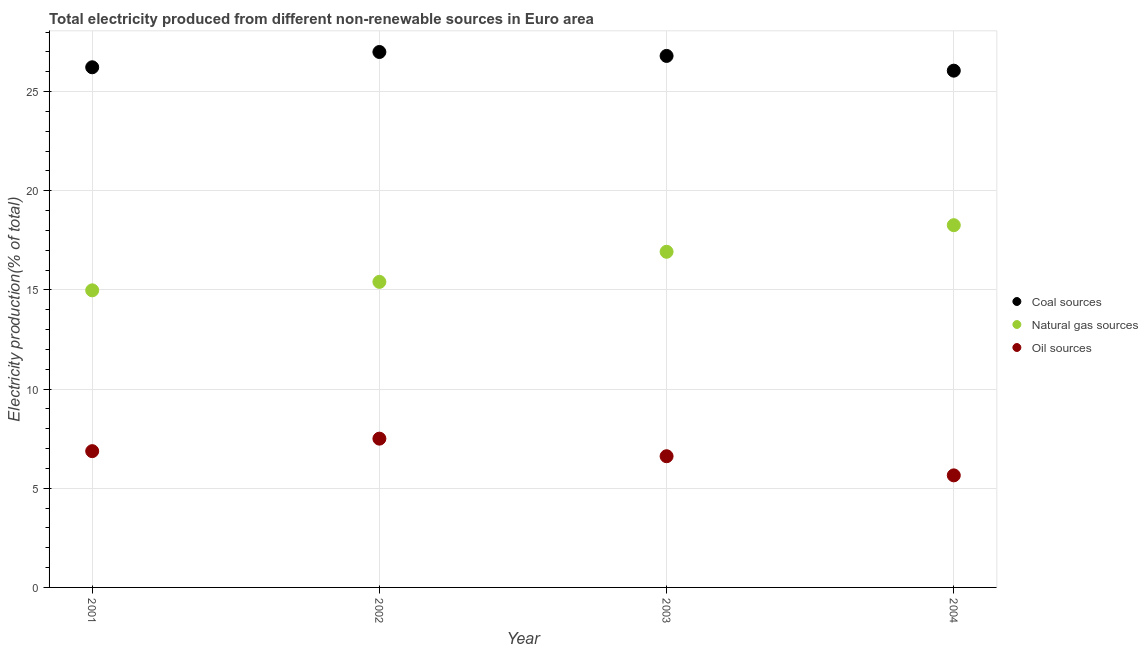How many different coloured dotlines are there?
Your answer should be compact. 3. Is the number of dotlines equal to the number of legend labels?
Give a very brief answer. Yes. What is the percentage of electricity produced by natural gas in 2002?
Ensure brevity in your answer.  15.41. Across all years, what is the maximum percentage of electricity produced by natural gas?
Make the answer very short. 18.26. Across all years, what is the minimum percentage of electricity produced by coal?
Ensure brevity in your answer.  26.06. In which year was the percentage of electricity produced by oil sources maximum?
Provide a short and direct response. 2002. In which year was the percentage of electricity produced by coal minimum?
Your response must be concise. 2004. What is the total percentage of electricity produced by oil sources in the graph?
Offer a very short reply. 26.64. What is the difference between the percentage of electricity produced by oil sources in 2001 and that in 2002?
Give a very brief answer. -0.63. What is the difference between the percentage of electricity produced by oil sources in 2002 and the percentage of electricity produced by natural gas in 2004?
Give a very brief answer. -10.76. What is the average percentage of electricity produced by coal per year?
Your answer should be very brief. 26.52. In the year 2001, what is the difference between the percentage of electricity produced by coal and percentage of electricity produced by oil sources?
Offer a terse response. 19.35. What is the ratio of the percentage of electricity produced by natural gas in 2002 to that in 2004?
Offer a very short reply. 0.84. Is the difference between the percentage of electricity produced by coal in 2002 and 2004 greater than the difference between the percentage of electricity produced by natural gas in 2002 and 2004?
Make the answer very short. Yes. What is the difference between the highest and the second highest percentage of electricity produced by oil sources?
Your answer should be very brief. 0.63. What is the difference between the highest and the lowest percentage of electricity produced by oil sources?
Provide a succinct answer. 1.85. In how many years, is the percentage of electricity produced by coal greater than the average percentage of electricity produced by coal taken over all years?
Your answer should be compact. 2. Is the sum of the percentage of electricity produced by coal in 2002 and 2004 greater than the maximum percentage of electricity produced by oil sources across all years?
Provide a short and direct response. Yes. Is the percentage of electricity produced by coal strictly less than the percentage of electricity produced by oil sources over the years?
Provide a short and direct response. No. How many dotlines are there?
Keep it short and to the point. 3. What is the difference between two consecutive major ticks on the Y-axis?
Your answer should be very brief. 5. Are the values on the major ticks of Y-axis written in scientific E-notation?
Keep it short and to the point. No. Does the graph contain any zero values?
Your answer should be very brief. No. Does the graph contain grids?
Offer a very short reply. Yes. Where does the legend appear in the graph?
Make the answer very short. Center right. What is the title of the graph?
Provide a succinct answer. Total electricity produced from different non-renewable sources in Euro area. Does "Taxes on income" appear as one of the legend labels in the graph?
Give a very brief answer. No. What is the Electricity production(% of total) in Coal sources in 2001?
Provide a short and direct response. 26.23. What is the Electricity production(% of total) in Natural gas sources in 2001?
Your answer should be very brief. 14.98. What is the Electricity production(% of total) in Oil sources in 2001?
Give a very brief answer. 6.87. What is the Electricity production(% of total) of Coal sources in 2002?
Offer a terse response. 27. What is the Electricity production(% of total) in Natural gas sources in 2002?
Give a very brief answer. 15.41. What is the Electricity production(% of total) of Oil sources in 2002?
Provide a succinct answer. 7.5. What is the Electricity production(% of total) of Coal sources in 2003?
Provide a succinct answer. 26.8. What is the Electricity production(% of total) of Natural gas sources in 2003?
Your answer should be compact. 16.92. What is the Electricity production(% of total) of Oil sources in 2003?
Ensure brevity in your answer.  6.62. What is the Electricity production(% of total) in Coal sources in 2004?
Provide a short and direct response. 26.06. What is the Electricity production(% of total) of Natural gas sources in 2004?
Offer a very short reply. 18.26. What is the Electricity production(% of total) in Oil sources in 2004?
Make the answer very short. 5.65. Across all years, what is the maximum Electricity production(% of total) of Coal sources?
Provide a short and direct response. 27. Across all years, what is the maximum Electricity production(% of total) of Natural gas sources?
Give a very brief answer. 18.26. Across all years, what is the maximum Electricity production(% of total) of Oil sources?
Make the answer very short. 7.5. Across all years, what is the minimum Electricity production(% of total) of Coal sources?
Make the answer very short. 26.06. Across all years, what is the minimum Electricity production(% of total) of Natural gas sources?
Your answer should be very brief. 14.98. Across all years, what is the minimum Electricity production(% of total) of Oil sources?
Your answer should be very brief. 5.65. What is the total Electricity production(% of total) of Coal sources in the graph?
Provide a short and direct response. 106.08. What is the total Electricity production(% of total) of Natural gas sources in the graph?
Keep it short and to the point. 65.57. What is the total Electricity production(% of total) in Oil sources in the graph?
Provide a succinct answer. 26.64. What is the difference between the Electricity production(% of total) in Coal sources in 2001 and that in 2002?
Keep it short and to the point. -0.77. What is the difference between the Electricity production(% of total) in Natural gas sources in 2001 and that in 2002?
Your answer should be very brief. -0.43. What is the difference between the Electricity production(% of total) in Oil sources in 2001 and that in 2002?
Offer a terse response. -0.63. What is the difference between the Electricity production(% of total) of Coal sources in 2001 and that in 2003?
Provide a succinct answer. -0.57. What is the difference between the Electricity production(% of total) of Natural gas sources in 2001 and that in 2003?
Your response must be concise. -1.94. What is the difference between the Electricity production(% of total) of Oil sources in 2001 and that in 2003?
Your answer should be very brief. 0.26. What is the difference between the Electricity production(% of total) of Coal sources in 2001 and that in 2004?
Keep it short and to the point. 0.17. What is the difference between the Electricity production(% of total) in Natural gas sources in 2001 and that in 2004?
Keep it short and to the point. -3.28. What is the difference between the Electricity production(% of total) in Oil sources in 2001 and that in 2004?
Keep it short and to the point. 1.22. What is the difference between the Electricity production(% of total) of Coal sources in 2002 and that in 2003?
Provide a succinct answer. 0.2. What is the difference between the Electricity production(% of total) of Natural gas sources in 2002 and that in 2003?
Offer a terse response. -1.52. What is the difference between the Electricity production(% of total) of Oil sources in 2002 and that in 2003?
Your answer should be compact. 0.89. What is the difference between the Electricity production(% of total) of Coal sources in 2002 and that in 2004?
Offer a terse response. 0.94. What is the difference between the Electricity production(% of total) in Natural gas sources in 2002 and that in 2004?
Give a very brief answer. -2.86. What is the difference between the Electricity production(% of total) of Oil sources in 2002 and that in 2004?
Provide a short and direct response. 1.85. What is the difference between the Electricity production(% of total) of Coal sources in 2003 and that in 2004?
Offer a very short reply. 0.74. What is the difference between the Electricity production(% of total) in Natural gas sources in 2003 and that in 2004?
Offer a terse response. -1.34. What is the difference between the Electricity production(% of total) in Oil sources in 2003 and that in 2004?
Provide a succinct answer. 0.96. What is the difference between the Electricity production(% of total) in Coal sources in 2001 and the Electricity production(% of total) in Natural gas sources in 2002?
Offer a terse response. 10.82. What is the difference between the Electricity production(% of total) in Coal sources in 2001 and the Electricity production(% of total) in Oil sources in 2002?
Provide a short and direct response. 18.72. What is the difference between the Electricity production(% of total) of Natural gas sources in 2001 and the Electricity production(% of total) of Oil sources in 2002?
Provide a short and direct response. 7.48. What is the difference between the Electricity production(% of total) in Coal sources in 2001 and the Electricity production(% of total) in Natural gas sources in 2003?
Your answer should be compact. 9.3. What is the difference between the Electricity production(% of total) in Coal sources in 2001 and the Electricity production(% of total) in Oil sources in 2003?
Provide a short and direct response. 19.61. What is the difference between the Electricity production(% of total) of Natural gas sources in 2001 and the Electricity production(% of total) of Oil sources in 2003?
Offer a very short reply. 8.36. What is the difference between the Electricity production(% of total) in Coal sources in 2001 and the Electricity production(% of total) in Natural gas sources in 2004?
Offer a very short reply. 7.96. What is the difference between the Electricity production(% of total) in Coal sources in 2001 and the Electricity production(% of total) in Oil sources in 2004?
Offer a very short reply. 20.58. What is the difference between the Electricity production(% of total) of Natural gas sources in 2001 and the Electricity production(% of total) of Oil sources in 2004?
Offer a terse response. 9.33. What is the difference between the Electricity production(% of total) of Coal sources in 2002 and the Electricity production(% of total) of Natural gas sources in 2003?
Provide a short and direct response. 10.07. What is the difference between the Electricity production(% of total) in Coal sources in 2002 and the Electricity production(% of total) in Oil sources in 2003?
Make the answer very short. 20.38. What is the difference between the Electricity production(% of total) in Natural gas sources in 2002 and the Electricity production(% of total) in Oil sources in 2003?
Your answer should be very brief. 8.79. What is the difference between the Electricity production(% of total) in Coal sources in 2002 and the Electricity production(% of total) in Natural gas sources in 2004?
Offer a very short reply. 8.73. What is the difference between the Electricity production(% of total) in Coal sources in 2002 and the Electricity production(% of total) in Oil sources in 2004?
Offer a very short reply. 21.35. What is the difference between the Electricity production(% of total) of Natural gas sources in 2002 and the Electricity production(% of total) of Oil sources in 2004?
Make the answer very short. 9.76. What is the difference between the Electricity production(% of total) in Coal sources in 2003 and the Electricity production(% of total) in Natural gas sources in 2004?
Offer a very short reply. 8.53. What is the difference between the Electricity production(% of total) in Coal sources in 2003 and the Electricity production(% of total) in Oil sources in 2004?
Offer a very short reply. 21.15. What is the difference between the Electricity production(% of total) in Natural gas sources in 2003 and the Electricity production(% of total) in Oil sources in 2004?
Ensure brevity in your answer.  11.27. What is the average Electricity production(% of total) in Coal sources per year?
Offer a very short reply. 26.52. What is the average Electricity production(% of total) of Natural gas sources per year?
Your response must be concise. 16.39. What is the average Electricity production(% of total) of Oil sources per year?
Provide a succinct answer. 6.66. In the year 2001, what is the difference between the Electricity production(% of total) in Coal sources and Electricity production(% of total) in Natural gas sources?
Provide a short and direct response. 11.25. In the year 2001, what is the difference between the Electricity production(% of total) of Coal sources and Electricity production(% of total) of Oil sources?
Offer a very short reply. 19.36. In the year 2001, what is the difference between the Electricity production(% of total) of Natural gas sources and Electricity production(% of total) of Oil sources?
Provide a short and direct response. 8.11. In the year 2002, what is the difference between the Electricity production(% of total) in Coal sources and Electricity production(% of total) in Natural gas sources?
Keep it short and to the point. 11.59. In the year 2002, what is the difference between the Electricity production(% of total) of Coal sources and Electricity production(% of total) of Oil sources?
Your answer should be compact. 19.49. In the year 2002, what is the difference between the Electricity production(% of total) of Natural gas sources and Electricity production(% of total) of Oil sources?
Your response must be concise. 7.9. In the year 2003, what is the difference between the Electricity production(% of total) in Coal sources and Electricity production(% of total) in Natural gas sources?
Offer a very short reply. 9.88. In the year 2003, what is the difference between the Electricity production(% of total) of Coal sources and Electricity production(% of total) of Oil sources?
Give a very brief answer. 20.18. In the year 2003, what is the difference between the Electricity production(% of total) of Natural gas sources and Electricity production(% of total) of Oil sources?
Your response must be concise. 10.31. In the year 2004, what is the difference between the Electricity production(% of total) in Coal sources and Electricity production(% of total) in Natural gas sources?
Provide a succinct answer. 7.79. In the year 2004, what is the difference between the Electricity production(% of total) of Coal sources and Electricity production(% of total) of Oil sources?
Your answer should be compact. 20.41. In the year 2004, what is the difference between the Electricity production(% of total) in Natural gas sources and Electricity production(% of total) in Oil sources?
Keep it short and to the point. 12.61. What is the ratio of the Electricity production(% of total) of Coal sources in 2001 to that in 2002?
Your answer should be very brief. 0.97. What is the ratio of the Electricity production(% of total) in Natural gas sources in 2001 to that in 2002?
Offer a very short reply. 0.97. What is the ratio of the Electricity production(% of total) in Oil sources in 2001 to that in 2002?
Provide a succinct answer. 0.92. What is the ratio of the Electricity production(% of total) of Coal sources in 2001 to that in 2003?
Ensure brevity in your answer.  0.98. What is the ratio of the Electricity production(% of total) of Natural gas sources in 2001 to that in 2003?
Provide a succinct answer. 0.89. What is the ratio of the Electricity production(% of total) of Oil sources in 2001 to that in 2003?
Your response must be concise. 1.04. What is the ratio of the Electricity production(% of total) in Coal sources in 2001 to that in 2004?
Provide a short and direct response. 1.01. What is the ratio of the Electricity production(% of total) of Natural gas sources in 2001 to that in 2004?
Your response must be concise. 0.82. What is the ratio of the Electricity production(% of total) in Oil sources in 2001 to that in 2004?
Make the answer very short. 1.22. What is the ratio of the Electricity production(% of total) of Coal sources in 2002 to that in 2003?
Ensure brevity in your answer.  1.01. What is the ratio of the Electricity production(% of total) in Natural gas sources in 2002 to that in 2003?
Your response must be concise. 0.91. What is the ratio of the Electricity production(% of total) in Oil sources in 2002 to that in 2003?
Your answer should be very brief. 1.13. What is the ratio of the Electricity production(% of total) of Coal sources in 2002 to that in 2004?
Provide a succinct answer. 1.04. What is the ratio of the Electricity production(% of total) in Natural gas sources in 2002 to that in 2004?
Keep it short and to the point. 0.84. What is the ratio of the Electricity production(% of total) of Oil sources in 2002 to that in 2004?
Ensure brevity in your answer.  1.33. What is the ratio of the Electricity production(% of total) in Coal sources in 2003 to that in 2004?
Give a very brief answer. 1.03. What is the ratio of the Electricity production(% of total) of Natural gas sources in 2003 to that in 2004?
Make the answer very short. 0.93. What is the ratio of the Electricity production(% of total) of Oil sources in 2003 to that in 2004?
Offer a very short reply. 1.17. What is the difference between the highest and the second highest Electricity production(% of total) of Coal sources?
Provide a short and direct response. 0.2. What is the difference between the highest and the second highest Electricity production(% of total) of Natural gas sources?
Make the answer very short. 1.34. What is the difference between the highest and the second highest Electricity production(% of total) in Oil sources?
Your answer should be compact. 0.63. What is the difference between the highest and the lowest Electricity production(% of total) of Coal sources?
Make the answer very short. 0.94. What is the difference between the highest and the lowest Electricity production(% of total) in Natural gas sources?
Provide a short and direct response. 3.28. What is the difference between the highest and the lowest Electricity production(% of total) of Oil sources?
Ensure brevity in your answer.  1.85. 